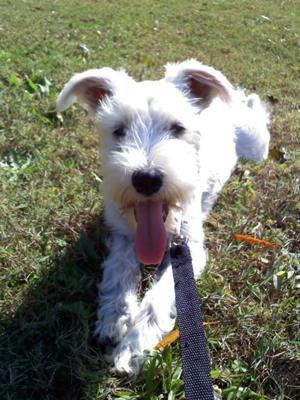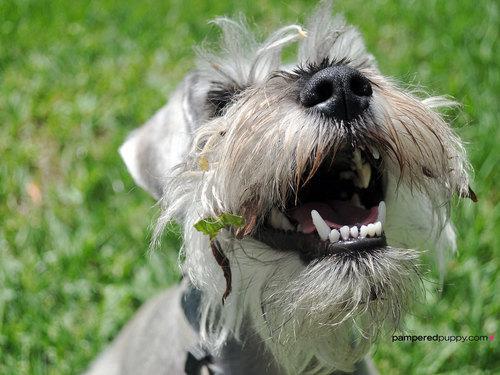The first image is the image on the left, the second image is the image on the right. Analyze the images presented: Is the assertion "Right image shows a dog looking upward, with mouth open." valid? Answer yes or no. Yes. The first image is the image on the left, the second image is the image on the right. Assess this claim about the two images: "The dog in the right image has its mouth open as it stands in the grass.". Correct or not? Answer yes or no. Yes. 